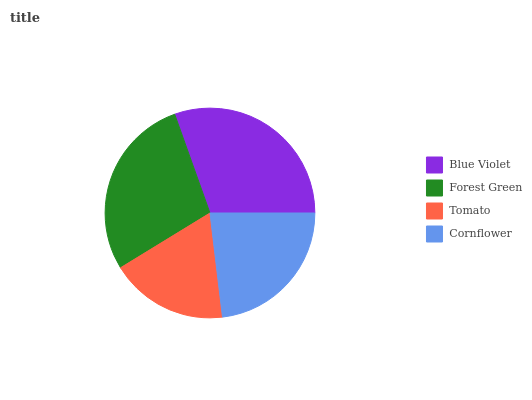Is Tomato the minimum?
Answer yes or no. Yes. Is Blue Violet the maximum?
Answer yes or no. Yes. Is Forest Green the minimum?
Answer yes or no. No. Is Forest Green the maximum?
Answer yes or no. No. Is Blue Violet greater than Forest Green?
Answer yes or no. Yes. Is Forest Green less than Blue Violet?
Answer yes or no. Yes. Is Forest Green greater than Blue Violet?
Answer yes or no. No. Is Blue Violet less than Forest Green?
Answer yes or no. No. Is Forest Green the high median?
Answer yes or no. Yes. Is Cornflower the low median?
Answer yes or no. Yes. Is Blue Violet the high median?
Answer yes or no. No. Is Blue Violet the low median?
Answer yes or no. No. 